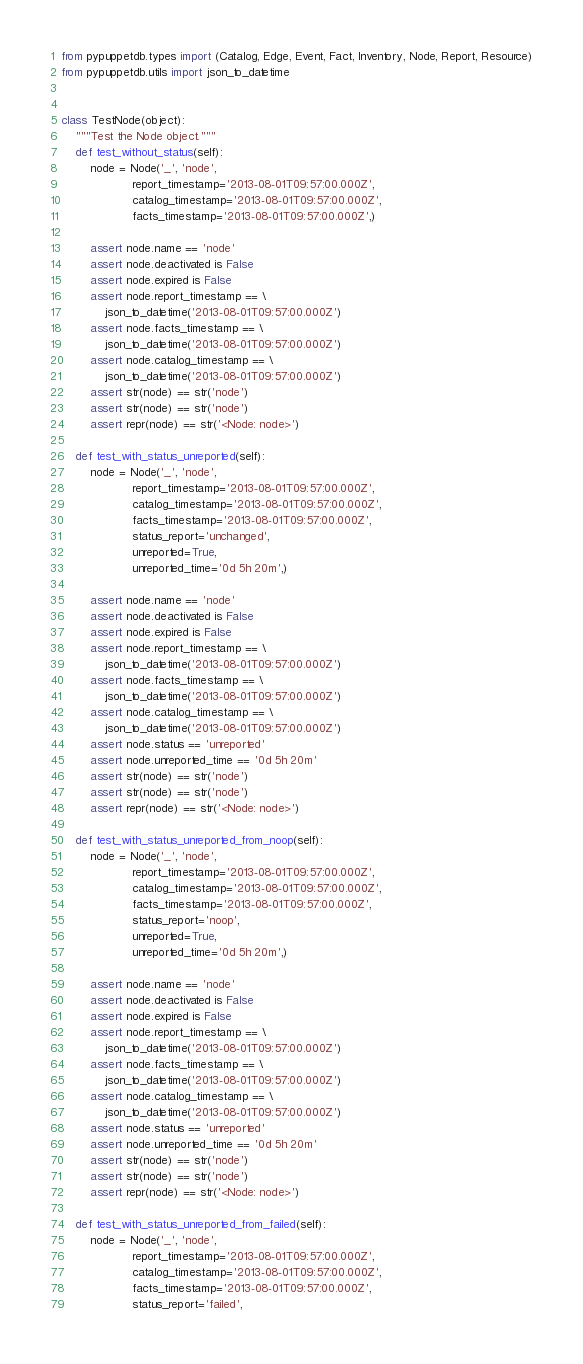Convert code to text. <code><loc_0><loc_0><loc_500><loc_500><_Python_>from pypuppetdb.types import (Catalog, Edge, Event, Fact, Inventory, Node, Report, Resource)
from pypuppetdb.utils import json_to_datetime


class TestNode(object):
    """Test the Node object."""
    def test_without_status(self):
        node = Node('_', 'node',
                    report_timestamp='2013-08-01T09:57:00.000Z',
                    catalog_timestamp='2013-08-01T09:57:00.000Z',
                    facts_timestamp='2013-08-01T09:57:00.000Z',)

        assert node.name == 'node'
        assert node.deactivated is False
        assert node.expired is False
        assert node.report_timestamp == \
            json_to_datetime('2013-08-01T09:57:00.000Z')
        assert node.facts_timestamp == \
            json_to_datetime('2013-08-01T09:57:00.000Z')
        assert node.catalog_timestamp == \
            json_to_datetime('2013-08-01T09:57:00.000Z')
        assert str(node) == str('node')
        assert str(node) == str('node')
        assert repr(node) == str('<Node: node>')

    def test_with_status_unreported(self):
        node = Node('_', 'node',
                    report_timestamp='2013-08-01T09:57:00.000Z',
                    catalog_timestamp='2013-08-01T09:57:00.000Z',
                    facts_timestamp='2013-08-01T09:57:00.000Z',
                    status_report='unchanged',
                    unreported=True,
                    unreported_time='0d 5h 20m',)

        assert node.name == 'node'
        assert node.deactivated is False
        assert node.expired is False
        assert node.report_timestamp == \
            json_to_datetime('2013-08-01T09:57:00.000Z')
        assert node.facts_timestamp == \
            json_to_datetime('2013-08-01T09:57:00.000Z')
        assert node.catalog_timestamp == \
            json_to_datetime('2013-08-01T09:57:00.000Z')
        assert node.status == 'unreported'
        assert node.unreported_time == '0d 5h 20m'
        assert str(node) == str('node')
        assert str(node) == str('node')
        assert repr(node) == str('<Node: node>')

    def test_with_status_unreported_from_noop(self):
        node = Node('_', 'node',
                    report_timestamp='2013-08-01T09:57:00.000Z',
                    catalog_timestamp='2013-08-01T09:57:00.000Z',
                    facts_timestamp='2013-08-01T09:57:00.000Z',
                    status_report='noop',
                    unreported=True,
                    unreported_time='0d 5h 20m',)

        assert node.name == 'node'
        assert node.deactivated is False
        assert node.expired is False
        assert node.report_timestamp == \
            json_to_datetime('2013-08-01T09:57:00.000Z')
        assert node.facts_timestamp == \
            json_to_datetime('2013-08-01T09:57:00.000Z')
        assert node.catalog_timestamp == \
            json_to_datetime('2013-08-01T09:57:00.000Z')
        assert node.status == 'unreported'
        assert node.unreported_time == '0d 5h 20m'
        assert str(node) == str('node')
        assert str(node) == str('node')
        assert repr(node) == str('<Node: node>')

    def test_with_status_unreported_from_failed(self):
        node = Node('_', 'node',
                    report_timestamp='2013-08-01T09:57:00.000Z',
                    catalog_timestamp='2013-08-01T09:57:00.000Z',
                    facts_timestamp='2013-08-01T09:57:00.000Z',
                    status_report='failed',</code> 